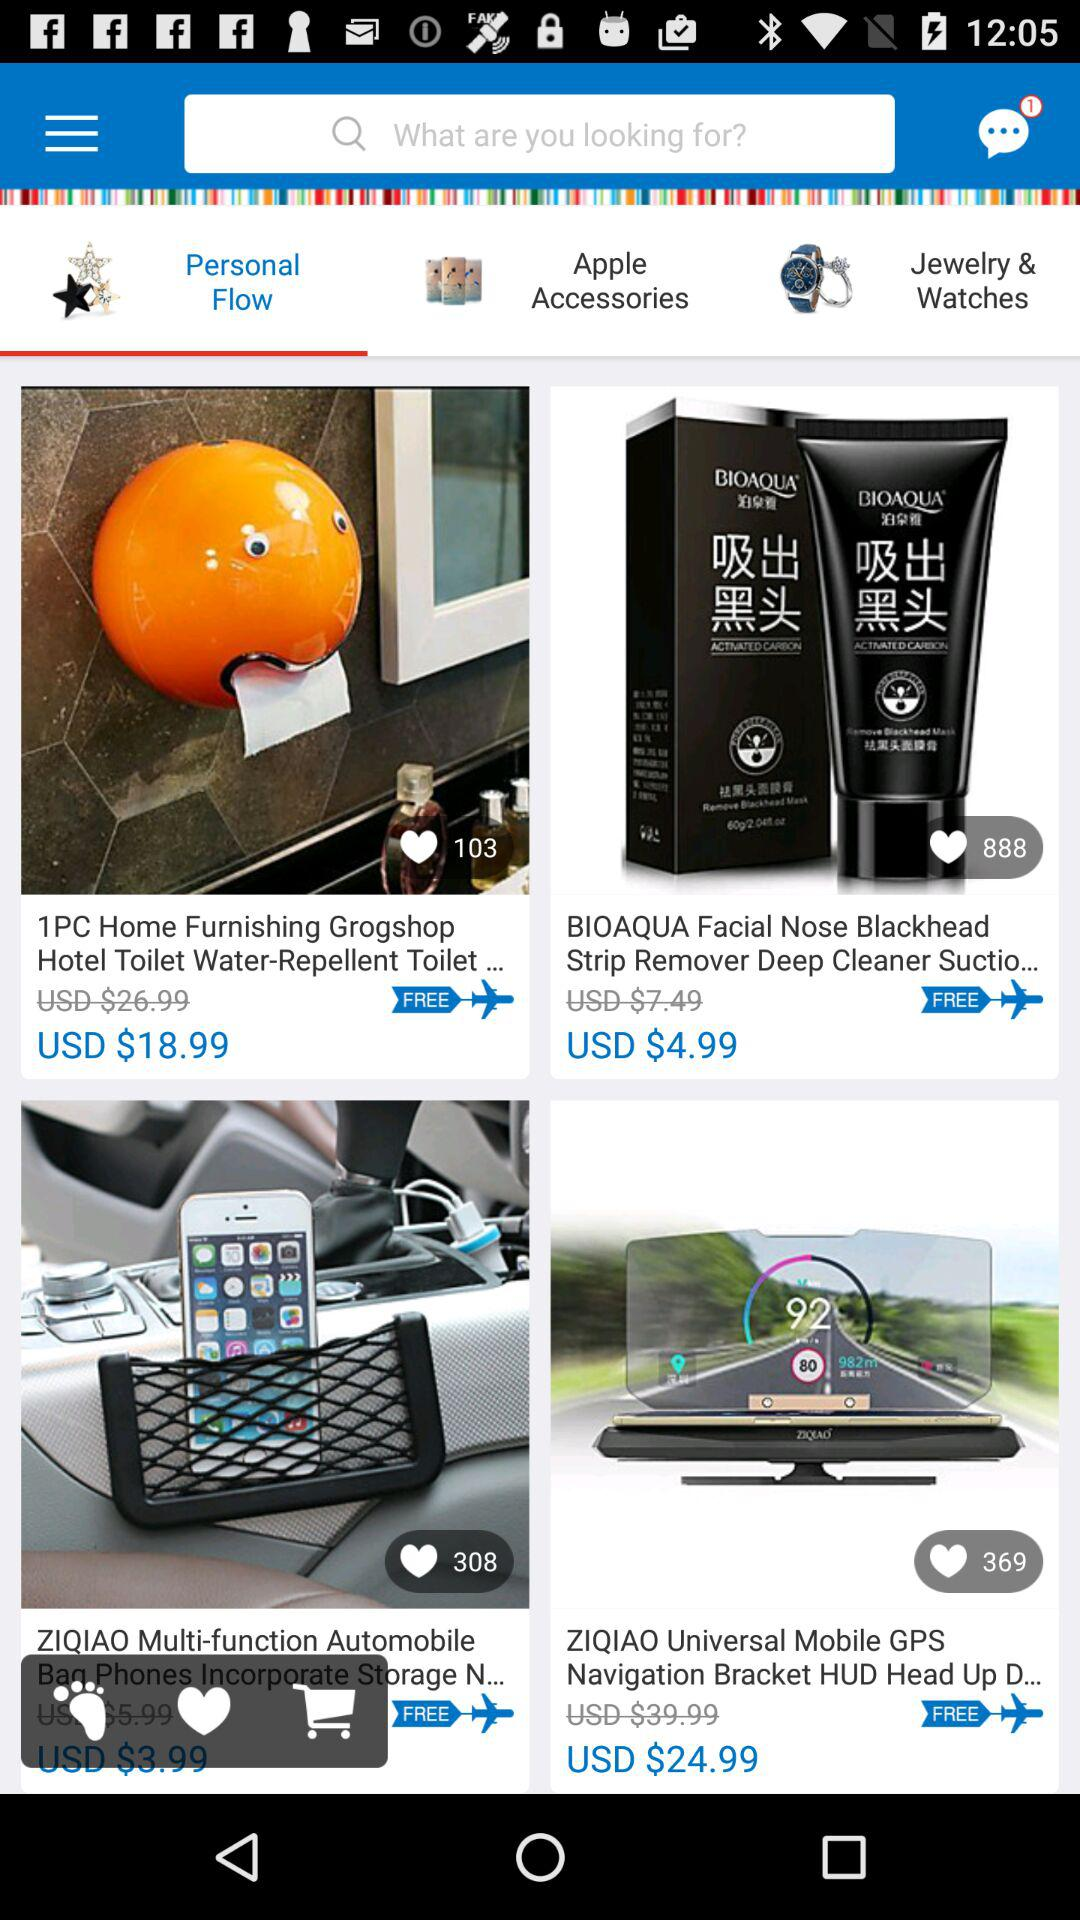What is the original price of the "BIOAQUA Facial Nose Blackhead Strip Remover Deep Cleaner Suctio..."? The original price of the "BIOAQUA Facial Nose Blackhead Strip Remover Deep Cleaner Suctio..." is USD $7.49. 